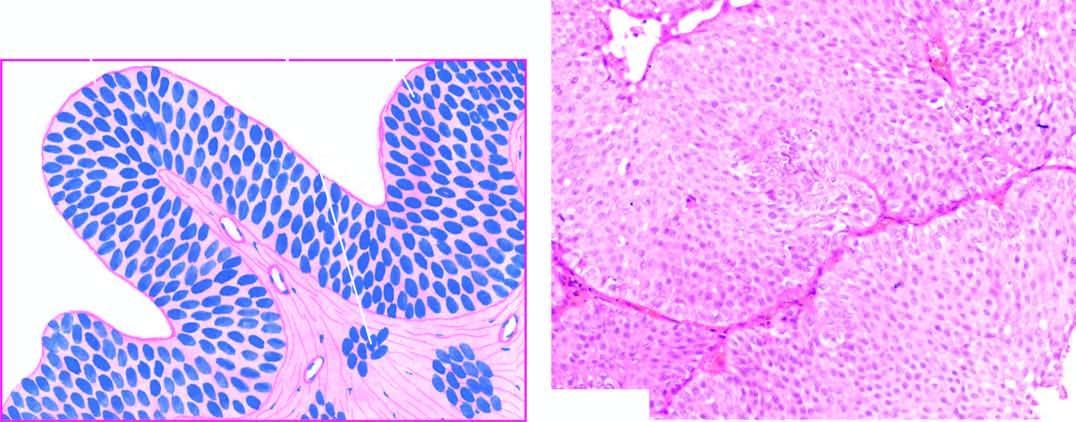s the heart increased in the number of layers of epithelium?
Answer the question using a single word or phrase. No 